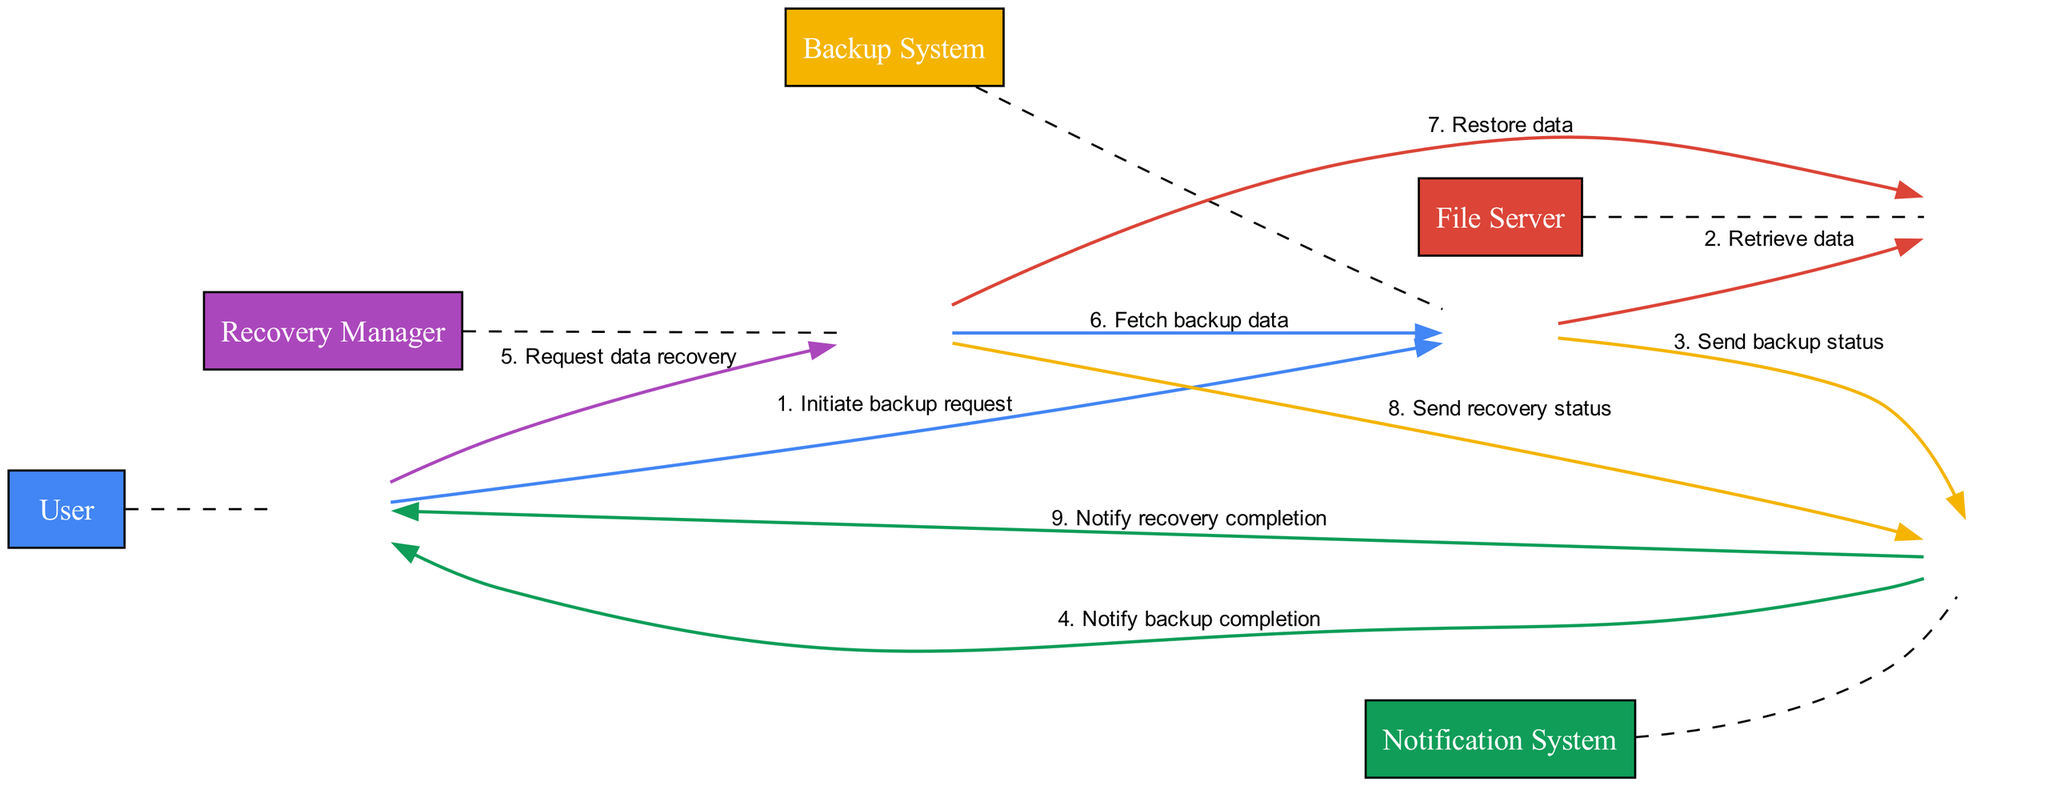What is the first action in the backup process? The first action that occurs in the backup process is initiated by the User, who sends a request to the Backup System to initiate a backup. This sets off the series of interactions that follow in the sequence diagram.
Answer: Initiate backup request How many entities are represented in the diagram? By counting the distinct entities listed in the data, there are five entities: User, File Server, Backup System, Notification System, and Recovery Manager. Thus, the total number of entities present in the diagram is five.
Answer: Five Which entity retrieves data from the File Server? According to the interactions, the Backup System is responsible for retrieving data from the File Server as part of the backup process. It is the first entity that interacts with the File Server to collect the necessary data.
Answer: Backup System What action does the Notification System perform after the backup process? Following the completion of the backup process, the Notification System sends a notification to the User indicating the completion status of the backup, which is an essential step in keeping the user informed of the process's outcome.
Answer: Notify backup completion What is the last action in the recovery process? The last action in the recovery process involves the Notification System notifying the User about the completion of the recovery process. This confirms to the User that their requested data recovery has been successfully completed.
Answer: Notify recovery completion Who requests data recovery? In the sequence diagram, the User is the entity that initiates the data recovery process by sending a request to the Recovery Manager for specific files or data they wish to recover.
Answer: User Which component notifies users about the backup and recovery completion? The Notification System is responsible for notifying the users regarding both the backup and recovery completion. It facilitates communication about the status to the User at critical stages in both processes.
Answer: Notification System How many total interactions are shown in the diagram? By counting the lines that represent actions in the interactions between entities, there are nine interactions depicted in the diagram, each representing a specific action taken by an entity.
Answer: Nine Which entity sends recovery status notifications? The Recovery Manager is the entity responsible for sending notifications about the recovery status to the Notification System, which then communicates this to the User. It ensures that the User is updated on the progress of their recovery request.
Answer: Recovery Manager 